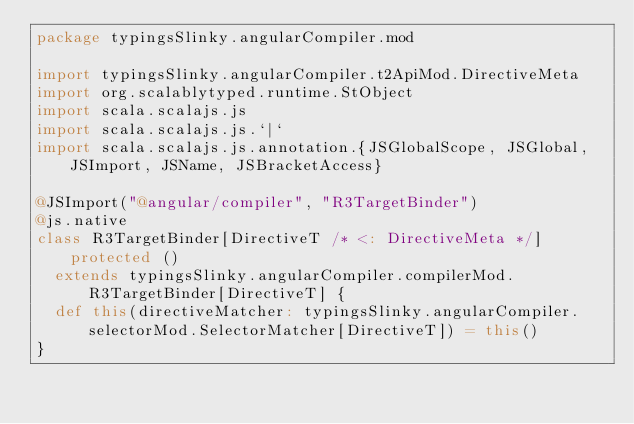<code> <loc_0><loc_0><loc_500><loc_500><_Scala_>package typingsSlinky.angularCompiler.mod

import typingsSlinky.angularCompiler.t2ApiMod.DirectiveMeta
import org.scalablytyped.runtime.StObject
import scala.scalajs.js
import scala.scalajs.js.`|`
import scala.scalajs.js.annotation.{JSGlobalScope, JSGlobal, JSImport, JSName, JSBracketAccess}

@JSImport("@angular/compiler", "R3TargetBinder")
@js.native
class R3TargetBinder[DirectiveT /* <: DirectiveMeta */] protected ()
  extends typingsSlinky.angularCompiler.compilerMod.R3TargetBinder[DirectiveT] {
  def this(directiveMatcher: typingsSlinky.angularCompiler.selectorMod.SelectorMatcher[DirectiveT]) = this()
}
</code> 